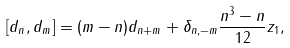<formula> <loc_0><loc_0><loc_500><loc_500>[ d _ { n } , d _ { m } ] = ( m - n ) d _ { n + m } + \delta _ { n , - m } \frac { n ^ { 3 } - n } { 1 2 } z _ { 1 } ,</formula> 